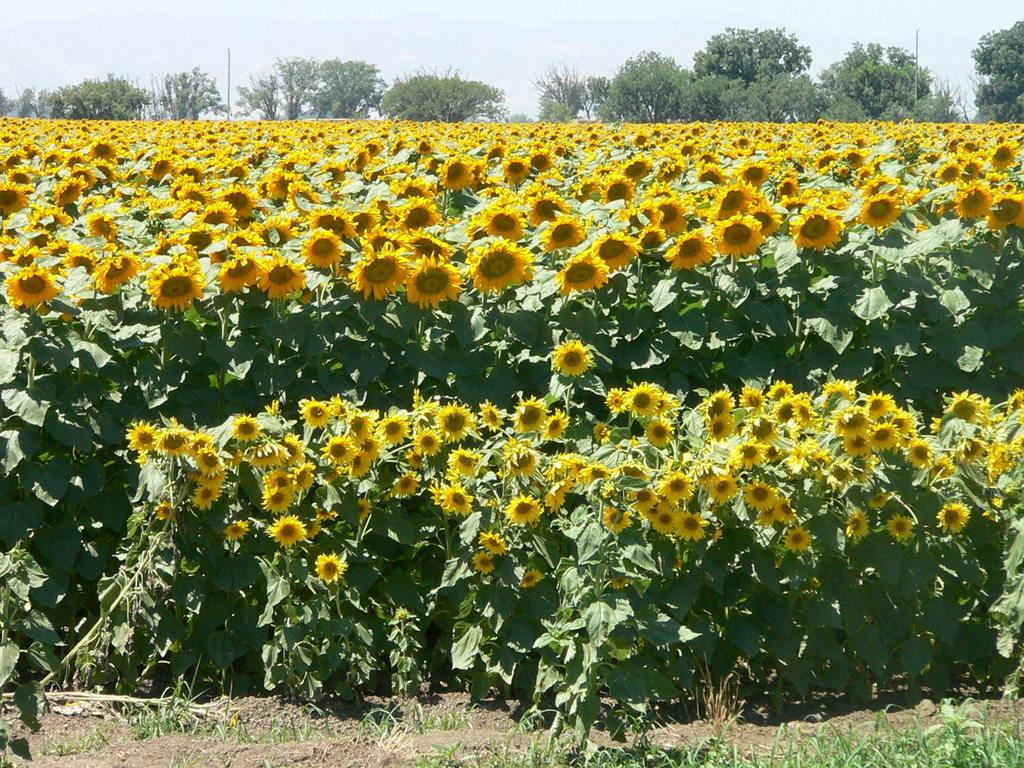What type of setting is depicted in the image? The image is an outside view. What kind of vegetation can be seen in the image? There are plants with flowers and trees in the image. What is visible at the top of the image? The sky is visible at the top of the image. Can you see any smoke coming from the chimney in the image? There is no chimney or smoke present in the image. Is there a boy swimming in the image? There is no boy or swimming activity depicted in the image. 